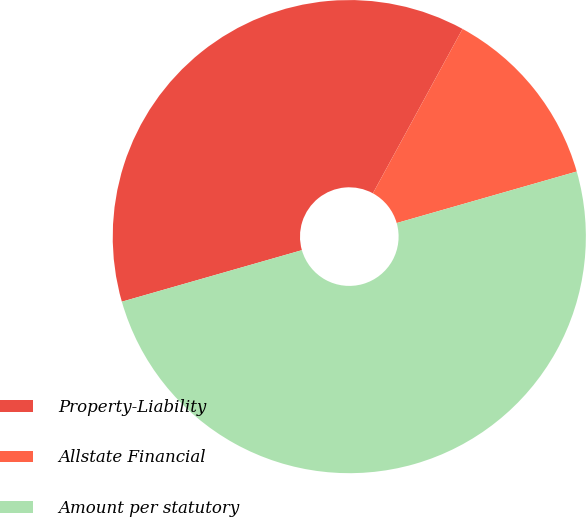Convert chart. <chart><loc_0><loc_0><loc_500><loc_500><pie_chart><fcel>Property-Liability<fcel>Allstate Financial<fcel>Amount per statutory<nl><fcel>37.38%<fcel>12.62%<fcel>50.0%<nl></chart> 